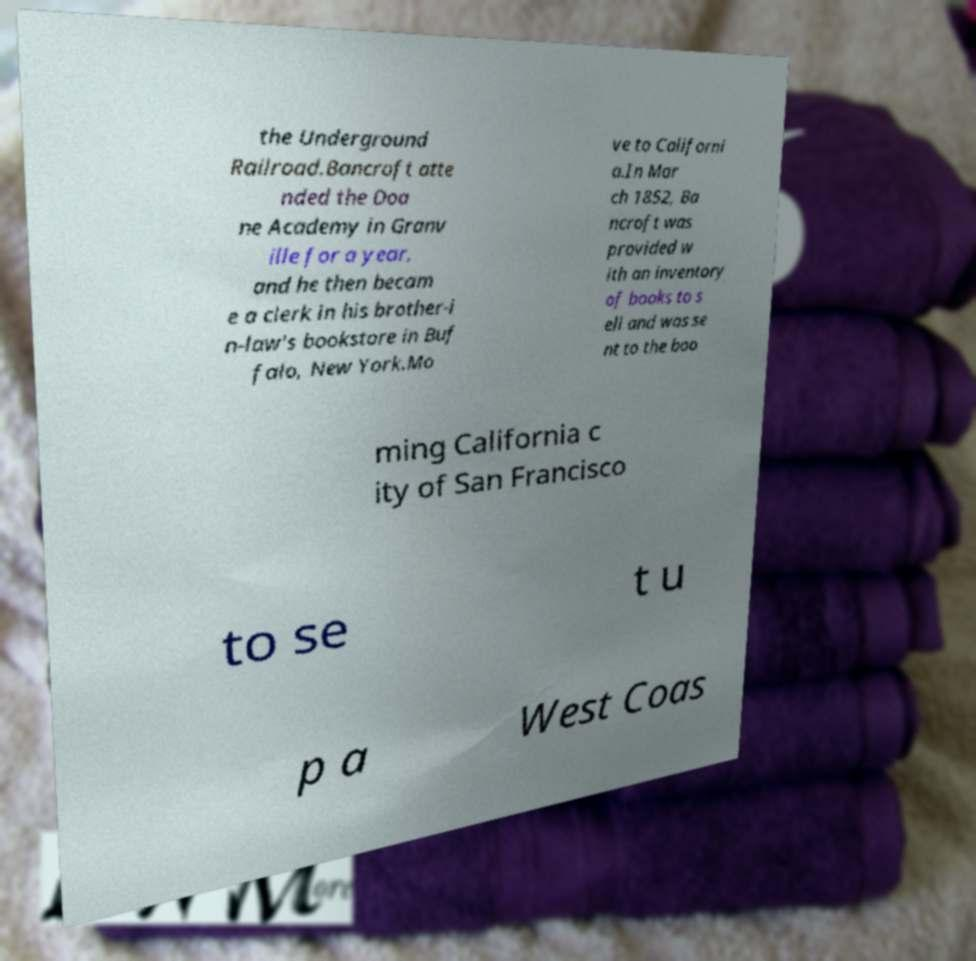Can you read and provide the text displayed in the image?This photo seems to have some interesting text. Can you extract and type it out for me? the Underground Railroad.Bancroft atte nded the Doa ne Academy in Granv ille for a year, and he then becam e a clerk in his brother-i n-law's bookstore in Buf falo, New York.Mo ve to Californi a.In Mar ch 1852, Ba ncroft was provided w ith an inventory of books to s ell and was se nt to the boo ming California c ity of San Francisco to se t u p a West Coas 